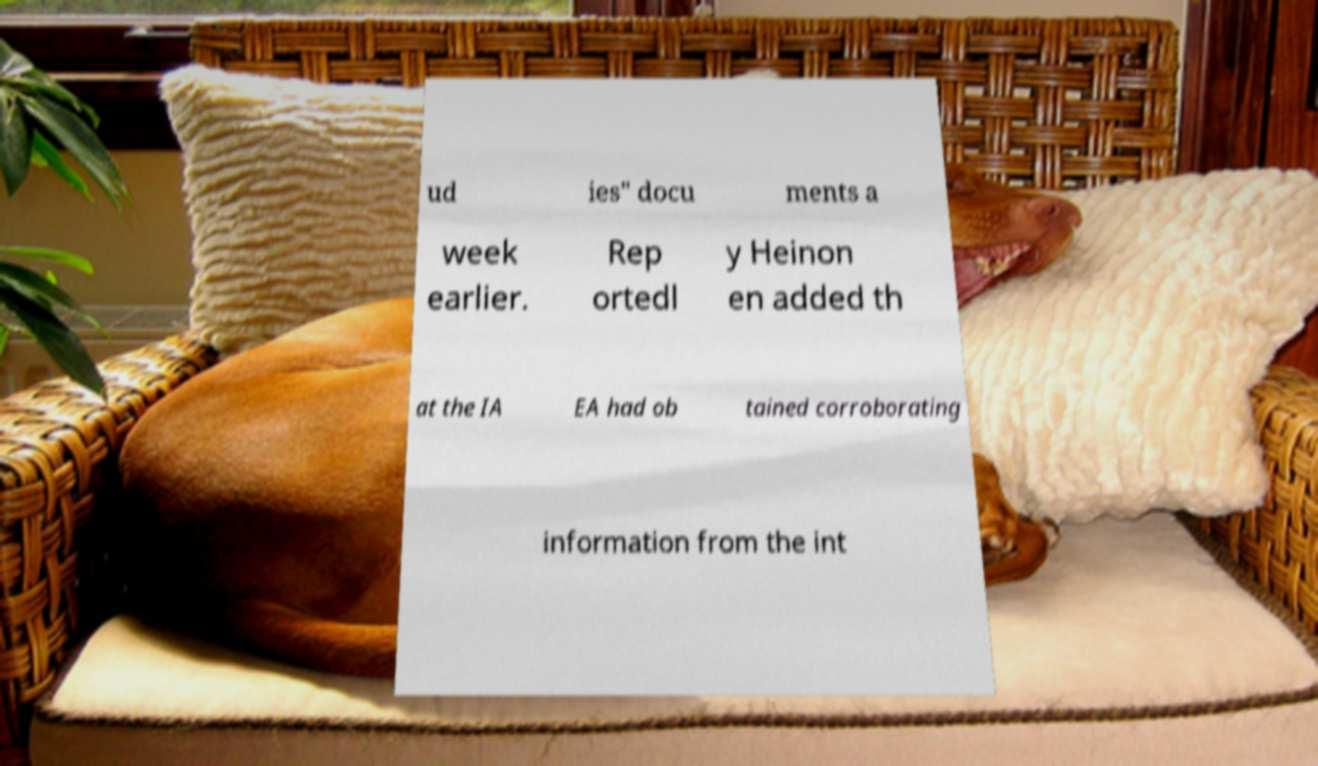Can you accurately transcribe the text from the provided image for me? ud ies" docu ments a week earlier. Rep ortedl y Heinon en added th at the IA EA had ob tained corroborating information from the int 